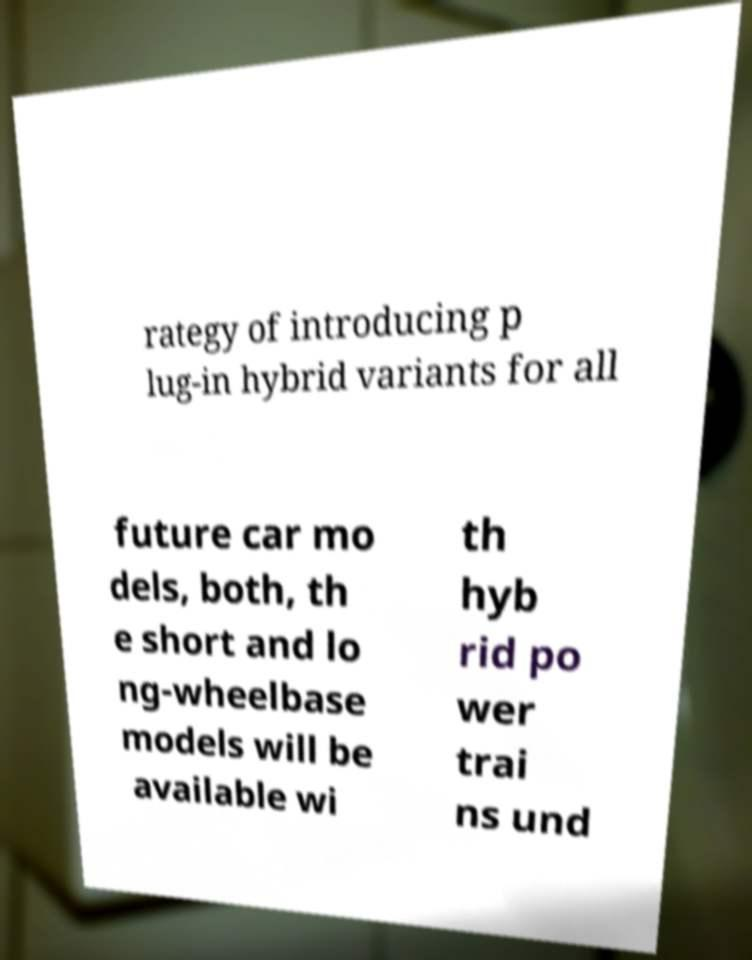For documentation purposes, I need the text within this image transcribed. Could you provide that? rategy of introducing p lug-in hybrid variants for all future car mo dels, both, th e short and lo ng-wheelbase models will be available wi th hyb rid po wer trai ns und 